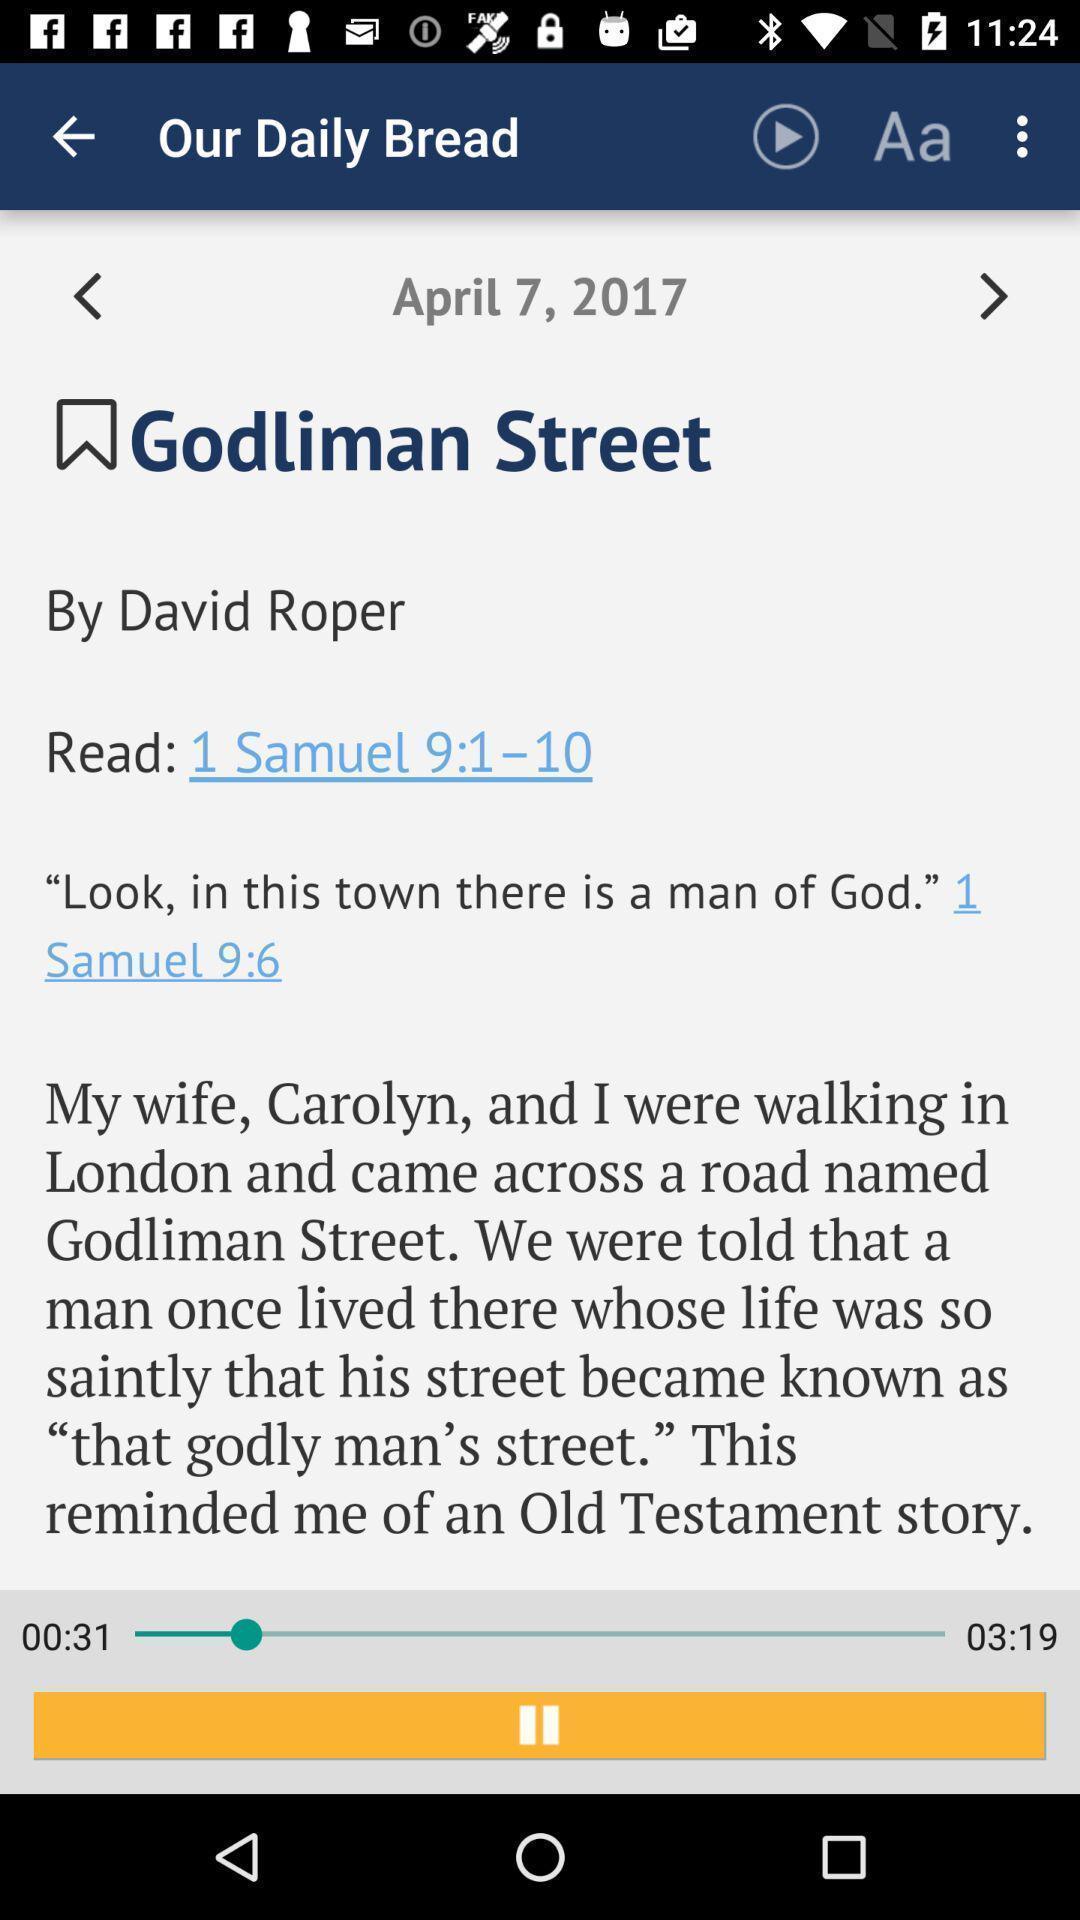What is the overall content of this screenshot? Screen shows daily bread reading. 